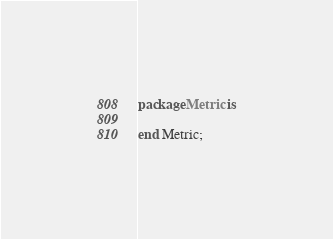Convert code to text. <code><loc_0><loc_0><loc_500><loc_500><_Ada_>package Metric is

end Metric;
</code> 